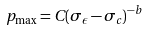Convert formula to latex. <formula><loc_0><loc_0><loc_500><loc_500>p _ { \max } = C ( \sigma _ { \epsilon } - \sigma _ { c } ) ^ { - b }</formula> 